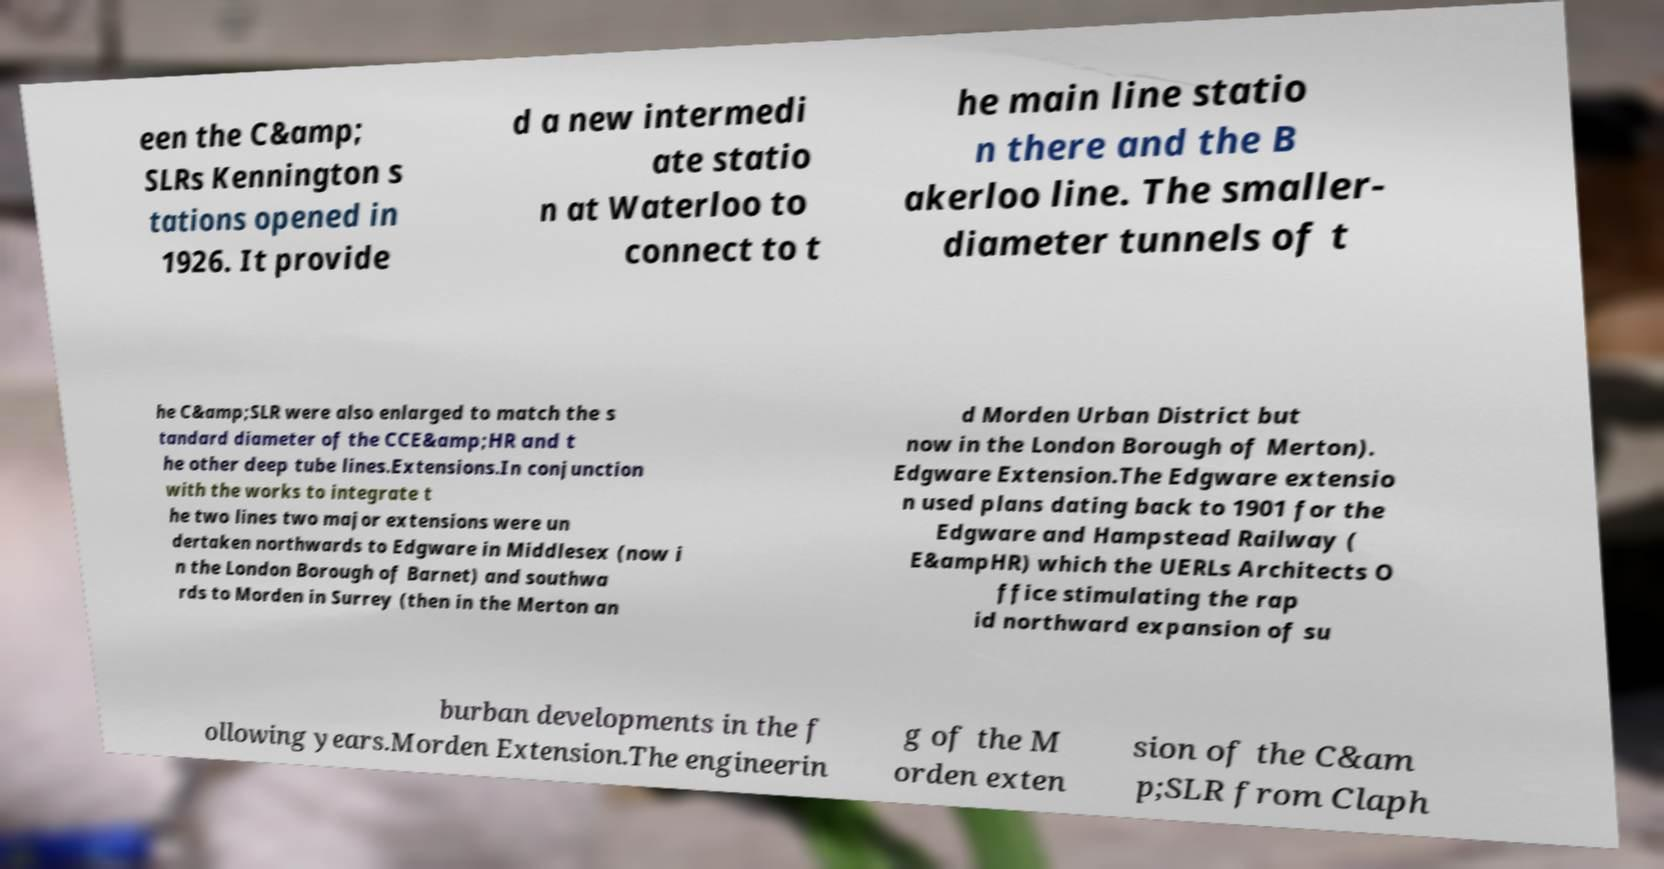For documentation purposes, I need the text within this image transcribed. Could you provide that? een the C&amp; SLRs Kennington s tations opened in 1926. It provide d a new intermedi ate statio n at Waterloo to connect to t he main line statio n there and the B akerloo line. The smaller- diameter tunnels of t he C&amp;SLR were also enlarged to match the s tandard diameter of the CCE&amp;HR and t he other deep tube lines.Extensions.In conjunction with the works to integrate t he two lines two major extensions were un dertaken northwards to Edgware in Middlesex (now i n the London Borough of Barnet) and southwa rds to Morden in Surrey (then in the Merton an d Morden Urban District but now in the London Borough of Merton). Edgware Extension.The Edgware extensio n used plans dating back to 1901 for the Edgware and Hampstead Railway ( E&ampHR) which the UERLs Architects O ffice stimulating the rap id northward expansion of su burban developments in the f ollowing years.Morden Extension.The engineerin g of the M orden exten sion of the C&am p;SLR from Claph 